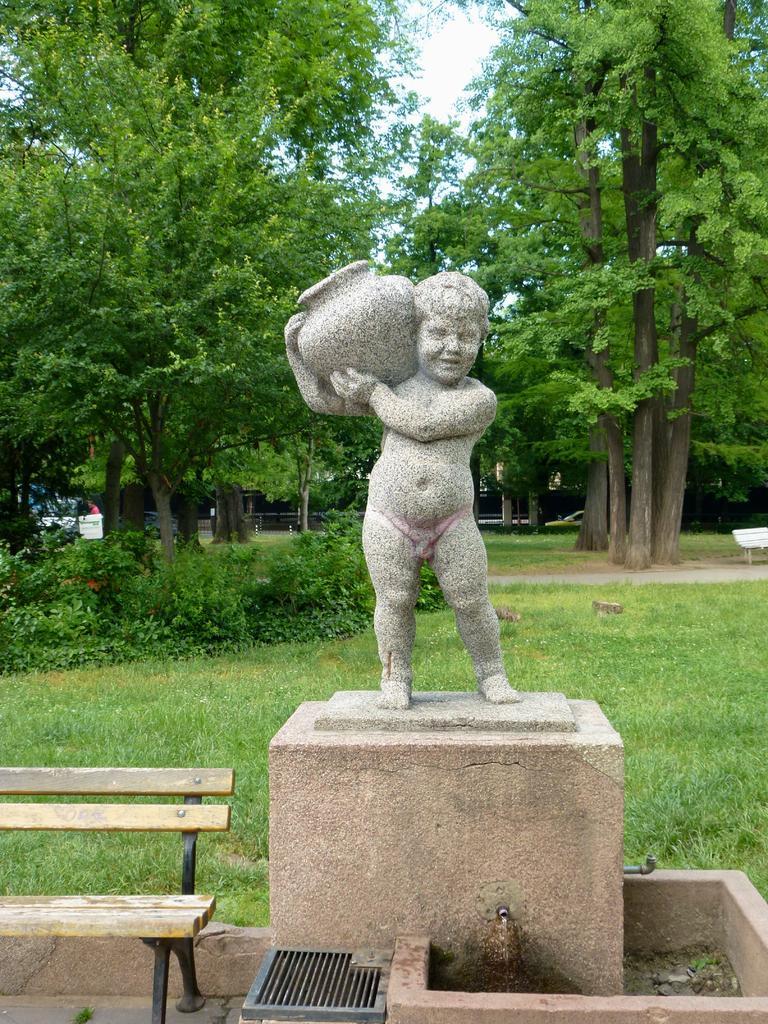Describe this image in one or two sentences. It is a garden with full of trees, plants, grass and we can find the bench and the sculpture of the child holding a pot. 